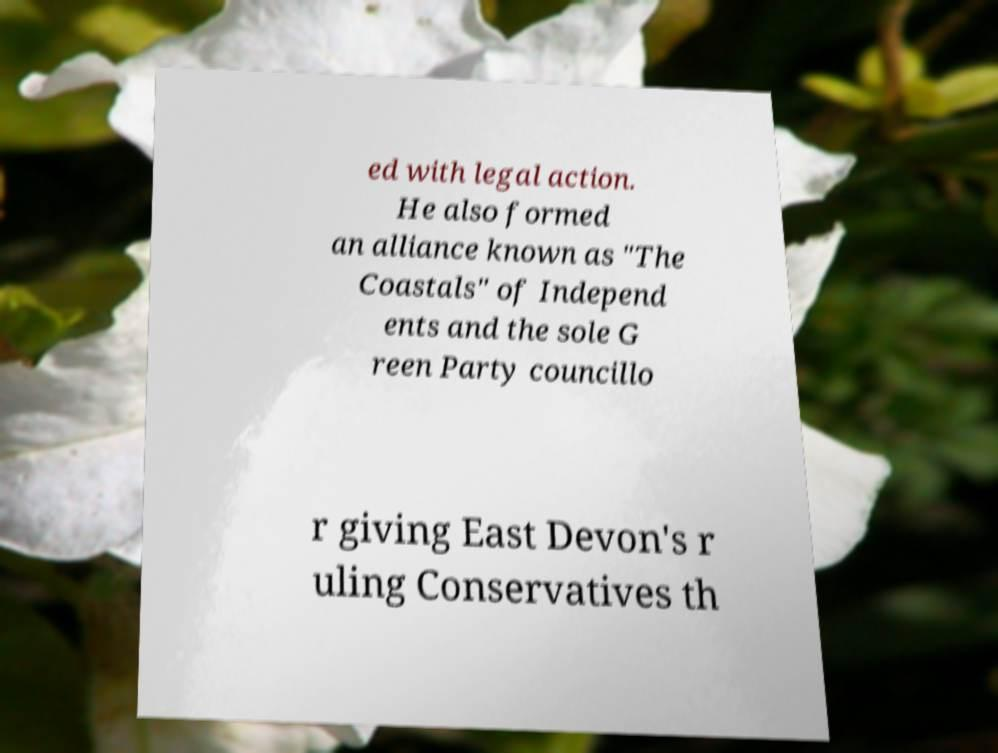Could you assist in decoding the text presented in this image and type it out clearly? ed with legal action. He also formed an alliance known as "The Coastals" of Independ ents and the sole G reen Party councillo r giving East Devon's r uling Conservatives th 